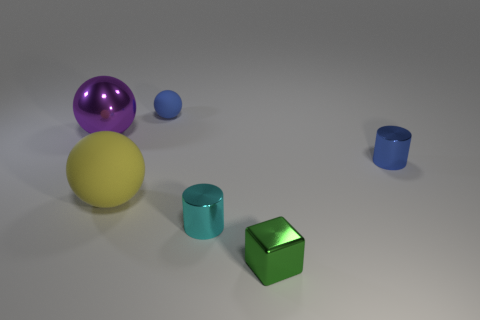Subtract all matte balls. How many balls are left? 1 Add 1 small spheres. How many objects exist? 7 Subtract all green spheres. Subtract all red cylinders. How many spheres are left? 3 Subtract all cylinders. How many objects are left? 4 Subtract all purple things. Subtract all yellow matte spheres. How many objects are left? 4 Add 2 blue balls. How many blue balls are left? 3 Add 3 cyan cylinders. How many cyan cylinders exist? 4 Subtract 0 yellow cylinders. How many objects are left? 6 